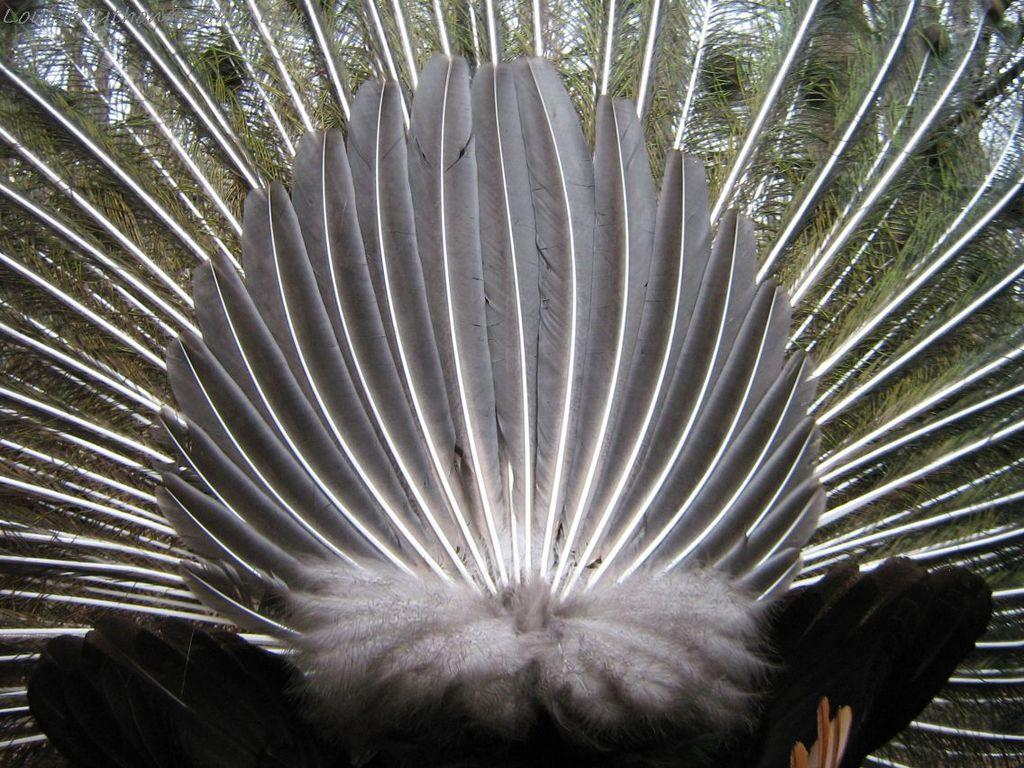What type of object can be seen in the image? There are feathers visible in the image. What animal do the feathers belong to? The feathers belong to a bird. Which part of the bird do the feathers come from? The feathers are from the back side of the bird. What type of notebook does the bird use to document its voyage in the image? There is no notebook or voyage depicted in the image; it only features feathers from a bird. 